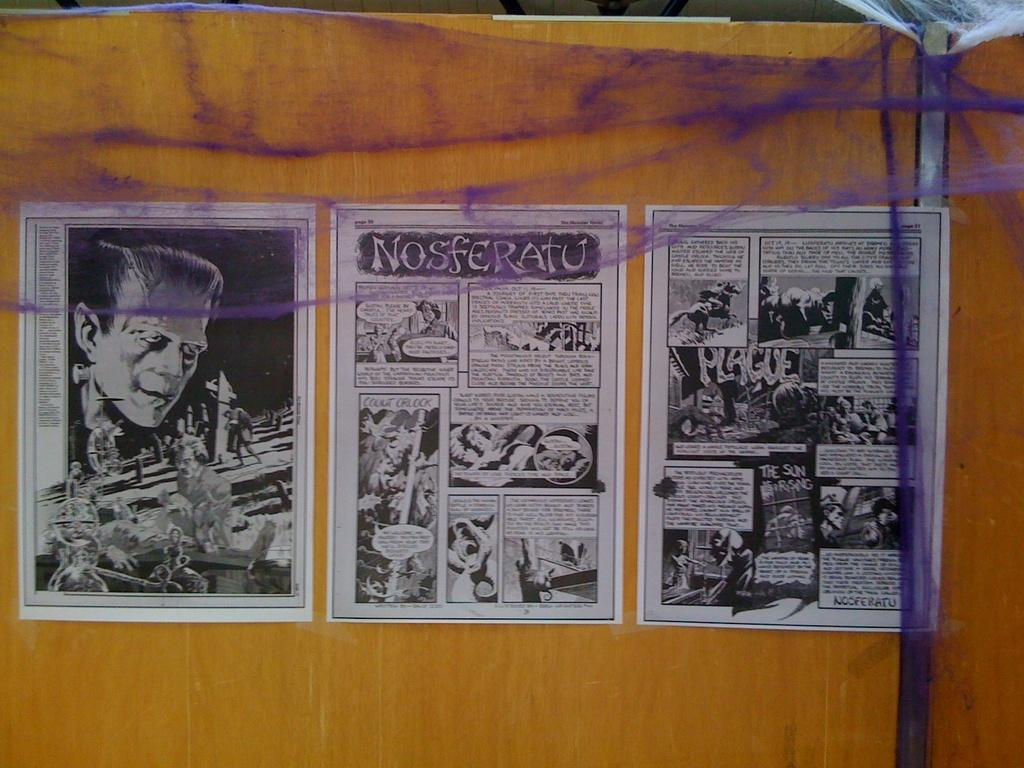Provide a one-sentence caption for the provided image. Comic strip of noseferatu on a paper on a brown board. 